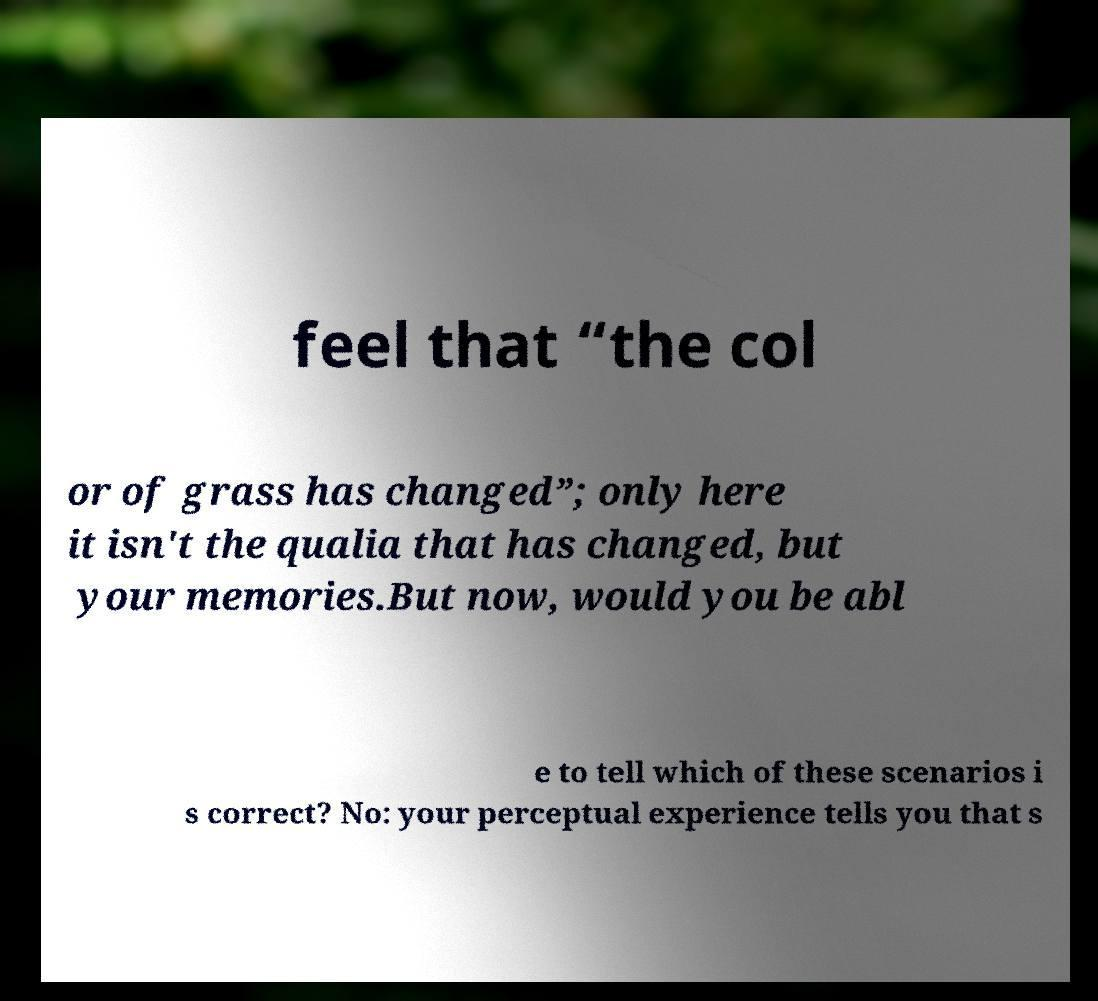Please read and relay the text visible in this image. What does it say? feel that “the col or of grass has changed”; only here it isn't the qualia that has changed, but your memories.But now, would you be abl e to tell which of these scenarios i s correct? No: your perceptual experience tells you that s 